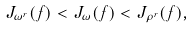Convert formula to latex. <formula><loc_0><loc_0><loc_500><loc_500>J _ { \omega ^ { r } } ( f ) < J _ { \omega } ( f ) < J _ { \rho ^ { r } } ( f ) ,</formula> 